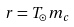Convert formula to latex. <formula><loc_0><loc_0><loc_500><loc_500>r = T _ { \odot } m _ { c }</formula> 